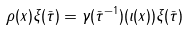<formula> <loc_0><loc_0><loc_500><loc_500>\rho ( x ) \xi ( \bar { \tau } ) = \gamma ( \bar { \tau } ^ { - 1 } ) ( \iota ( x ) ) \xi ( \bar { \tau } )</formula> 